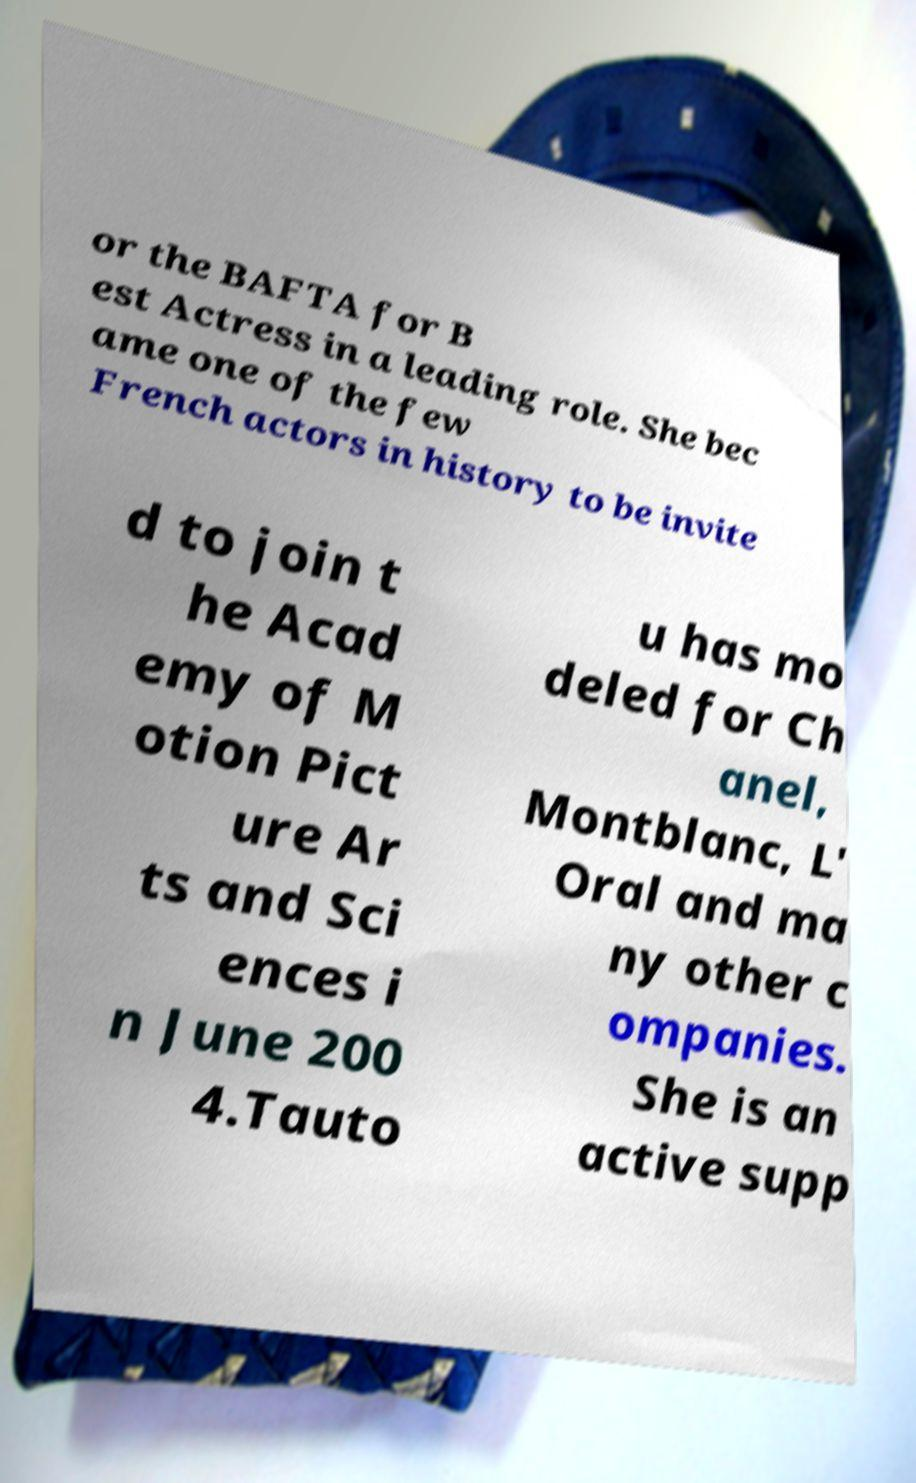Please read and relay the text visible in this image. What does it say? or the BAFTA for B est Actress in a leading role. She bec ame one of the few French actors in history to be invite d to join t he Acad emy of M otion Pict ure Ar ts and Sci ences i n June 200 4.Tauto u has mo deled for Ch anel, Montblanc, L' Oral and ma ny other c ompanies. She is an active supp 